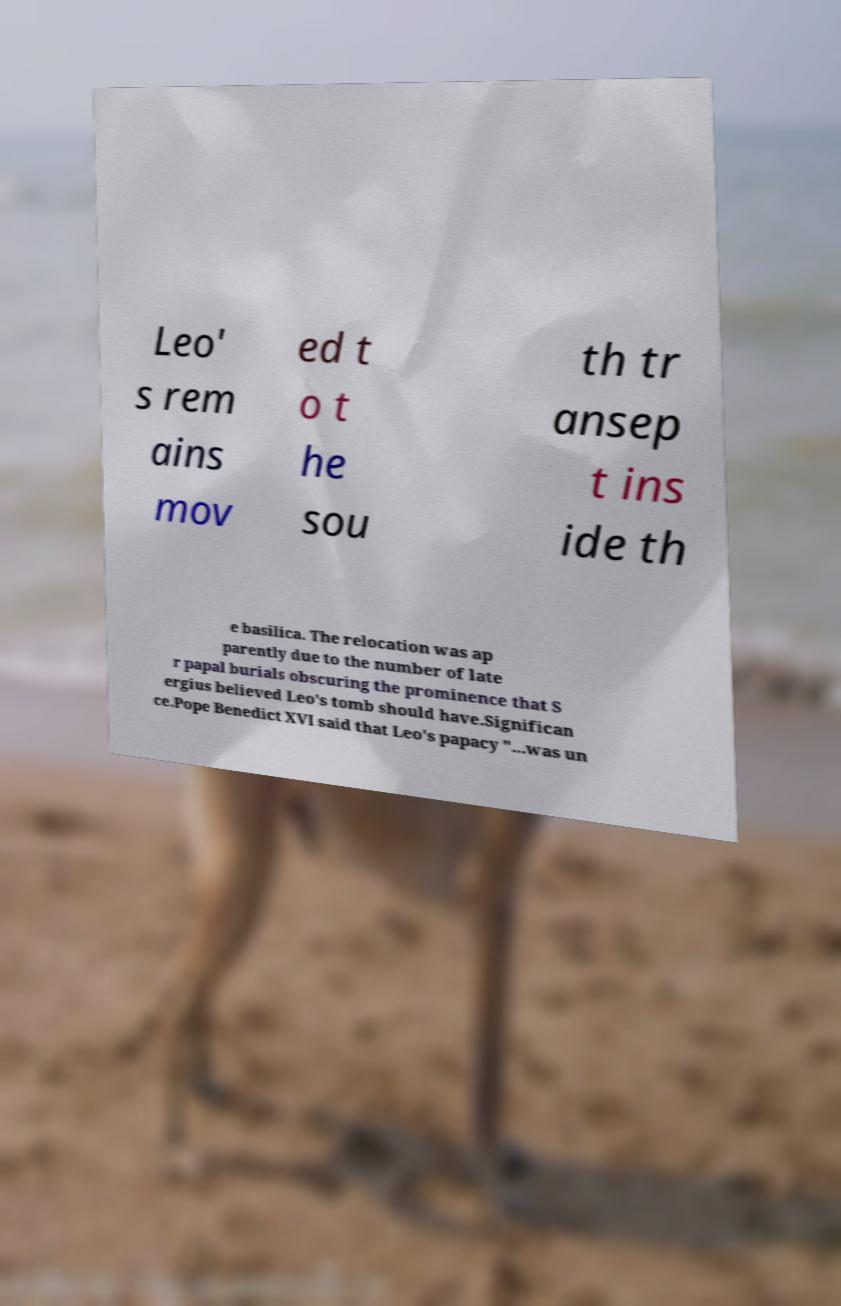Please identify and transcribe the text found in this image. Leo' s rem ains mov ed t o t he sou th tr ansep t ins ide th e basilica. The relocation was ap parently due to the number of late r papal burials obscuring the prominence that S ergius believed Leo's tomb should have.Significan ce.Pope Benedict XVI said that Leo's papacy "...was un 